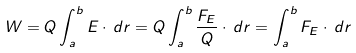Convert formula to latex. <formula><loc_0><loc_0><loc_500><loc_500>W = Q \int _ { a } ^ { b } E \cdot \, d r = Q \int _ { a } ^ { b } { \frac { F _ { E } } { Q } } \cdot \, d r = \int _ { a } ^ { b } F _ { E } \cdot \, d r</formula> 